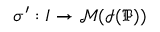Convert formula to latex. <formula><loc_0><loc_0><loc_500><loc_500>\sigma ^ { \prime } \colon I \rightarrow \mathcal { M } ( \mathcal { I } ( \mathfrak { P } ) )</formula> 